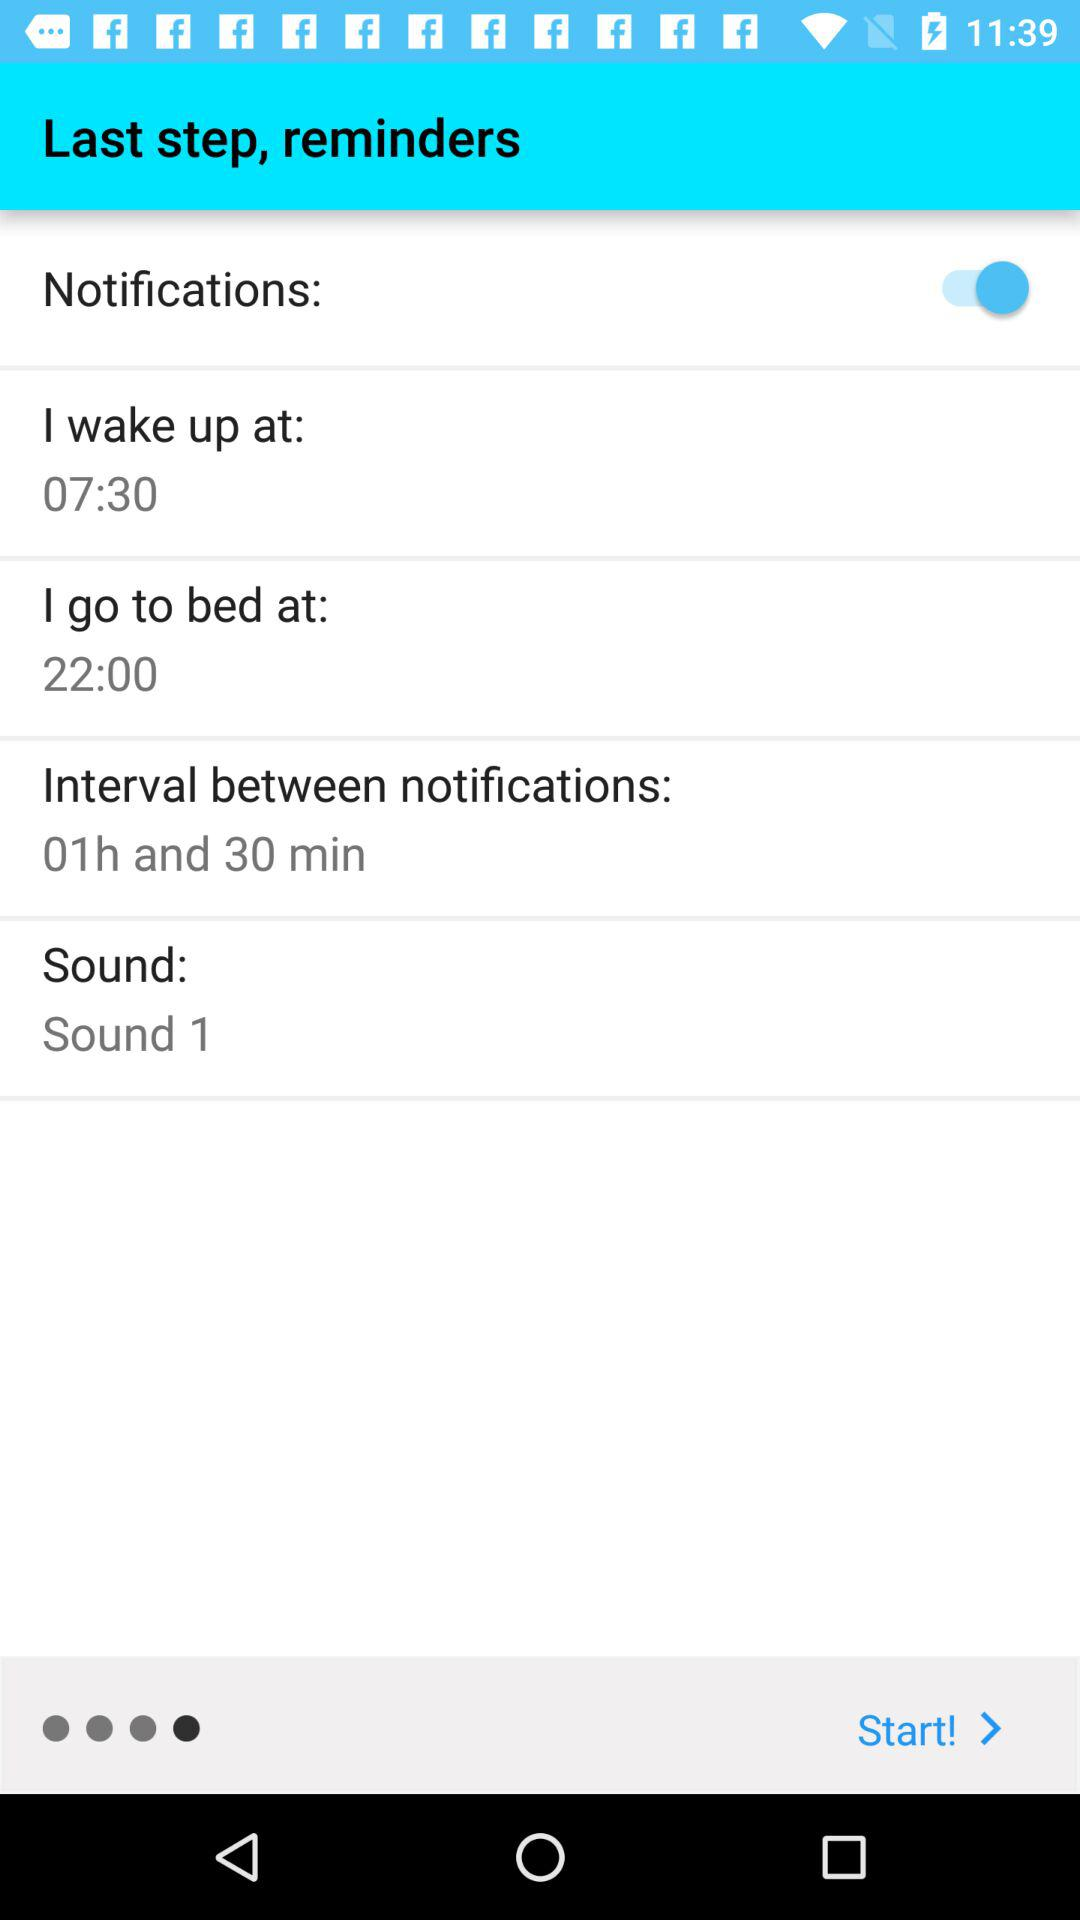What is the time to go to bed? The time is 22:00. 